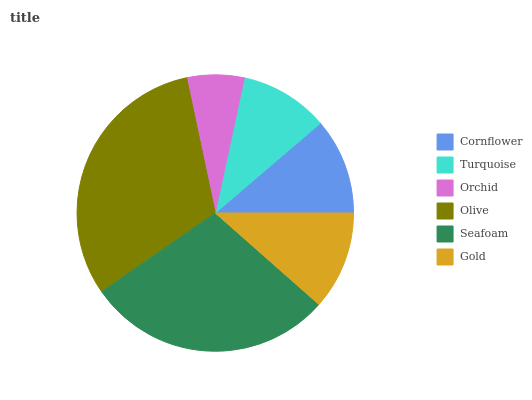Is Orchid the minimum?
Answer yes or no. Yes. Is Olive the maximum?
Answer yes or no. Yes. Is Turquoise the minimum?
Answer yes or no. No. Is Turquoise the maximum?
Answer yes or no. No. Is Cornflower greater than Turquoise?
Answer yes or no. Yes. Is Turquoise less than Cornflower?
Answer yes or no. Yes. Is Turquoise greater than Cornflower?
Answer yes or no. No. Is Cornflower less than Turquoise?
Answer yes or no. No. Is Gold the high median?
Answer yes or no. Yes. Is Cornflower the low median?
Answer yes or no. Yes. Is Turquoise the high median?
Answer yes or no. No. Is Orchid the low median?
Answer yes or no. No. 